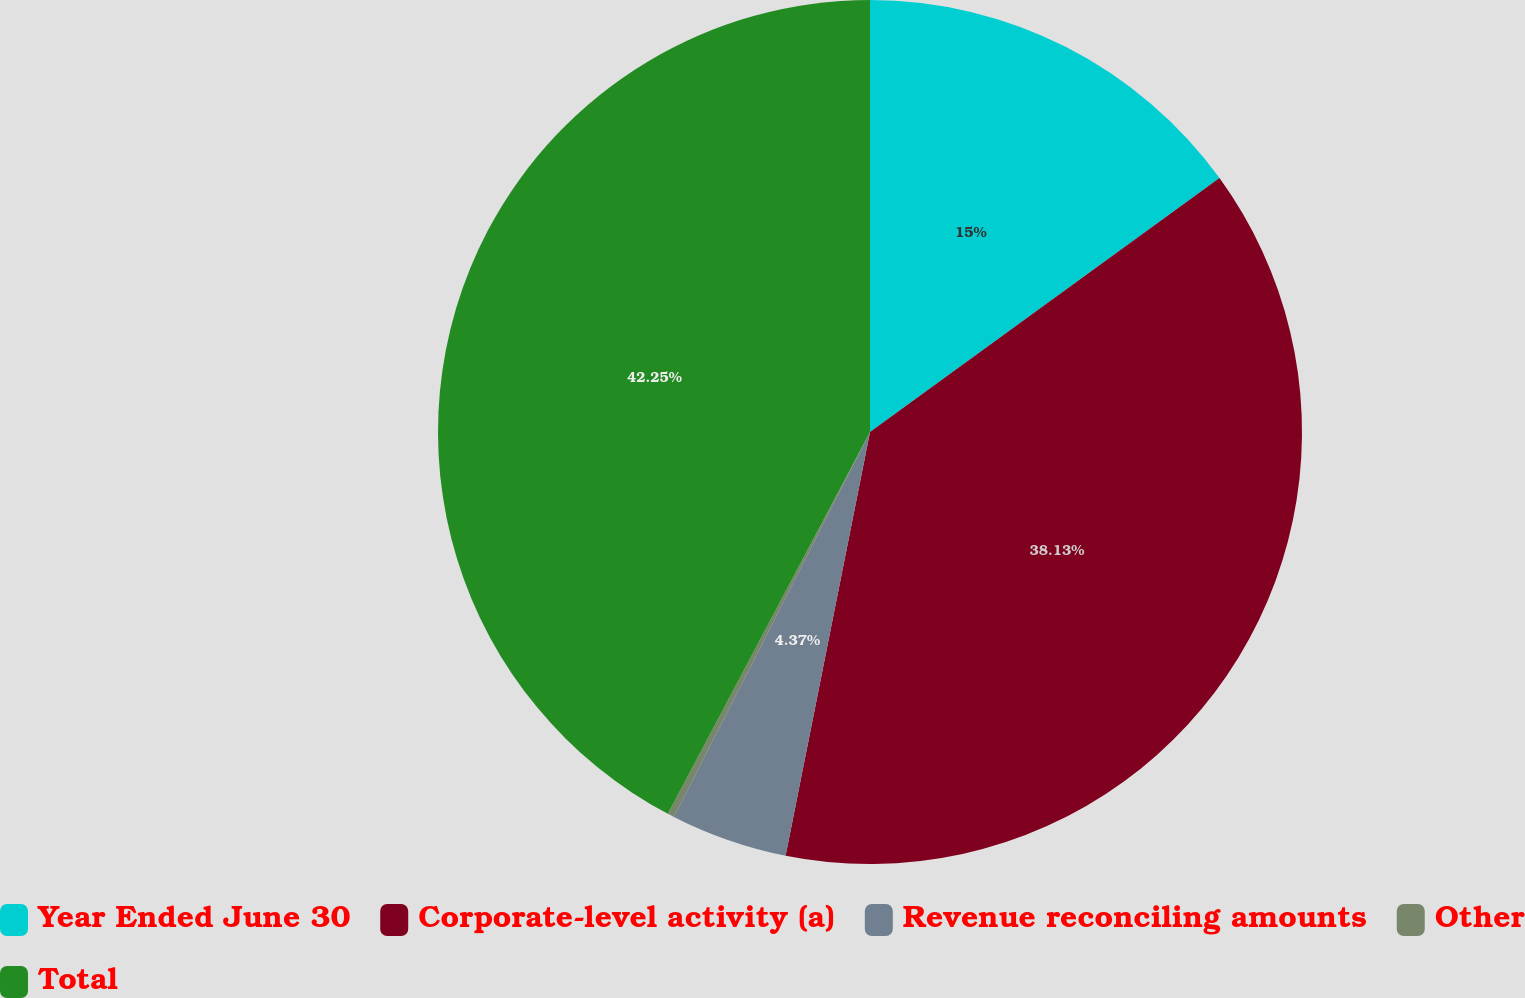Convert chart to OTSL. <chart><loc_0><loc_0><loc_500><loc_500><pie_chart><fcel>Year Ended June 30<fcel>Corporate-level activity (a)<fcel>Revenue reconciling amounts<fcel>Other<fcel>Total<nl><fcel>15.0%<fcel>38.13%<fcel>4.37%<fcel>0.25%<fcel>42.25%<nl></chart> 